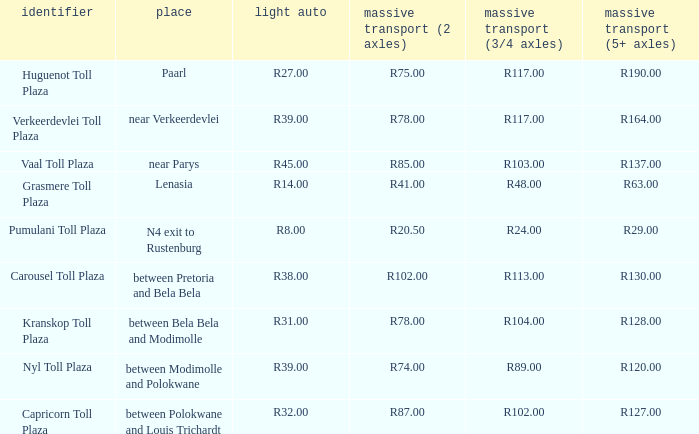What is the name of the plaza where the toll for heavy vehicles with 2 axles is r87.00? Capricorn Toll Plaza. 